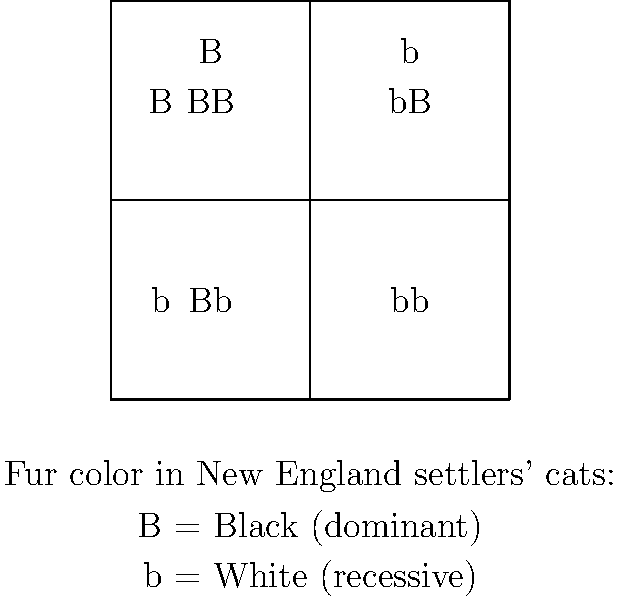In your research on early New England settlers, you come across records of their cats' fur colors. The trait for black fur (B) is dominant over white fur (b). If two heterozygous black cats (Bb) mate, what is the probability that their offspring will have white fur? To solve this problem, we'll use a Punnett square and follow these steps:

1. Identify the genotypes of the parent cats:
   Both parents are heterozygous (Bb) for the fur color trait.

2. Set up the Punnett square:
   - Place one parent's alleles (B and b) along the top
   - Place the other parent's alleles (B and b) along the left side

3. Fill in the Punnett square by combining the alleles:
   BB | Bb
   ---+---
   Bb | bb

4. Analyze the results:
   - BB: Black fur (homozygous dominant)
   - Bb: Black fur (heterozygous)
   - bb: White fur (homozygous recessive)

5. Calculate the probability:
   - Total number of possible outcomes: 4
   - Number of white fur outcomes (bb): 1
   - Probability = 1/4 = 0.25 or 25%

The probability of the offspring having white fur is 1/4 or 25%.
Answer: 1/4 or 25% 